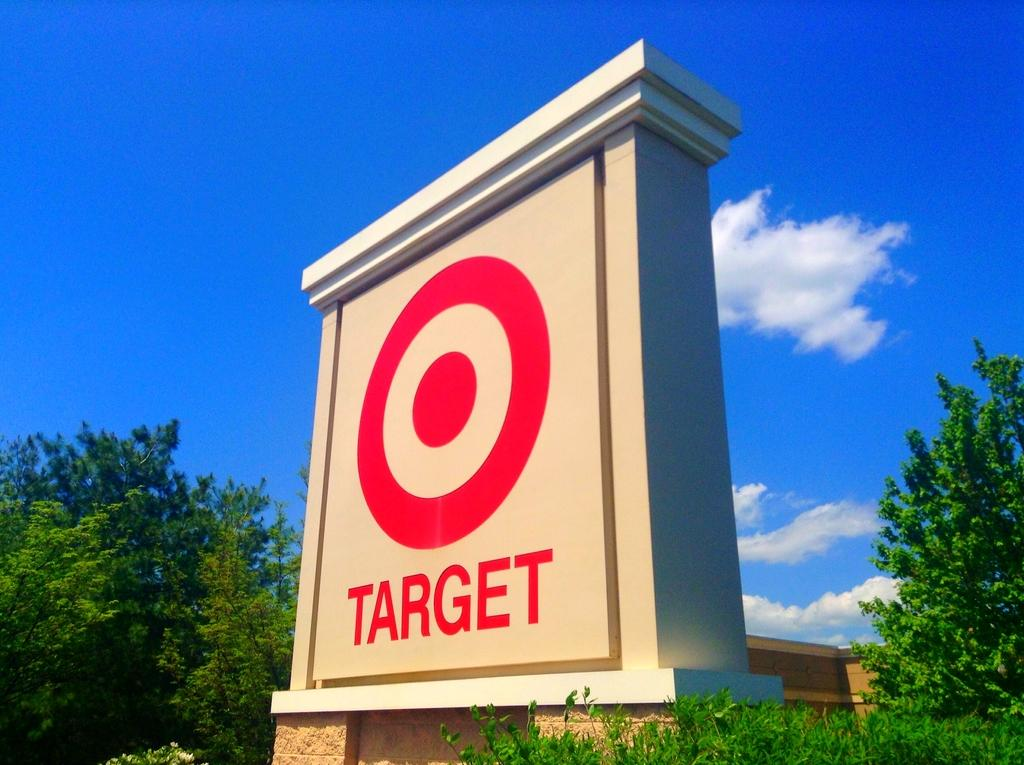What is the main object in the center of the image? There is a sign board in the center of the image. What type of vegetation can be seen on both sides of the image? There are trees on the right side and trees on the left side of the image. What is visible at the top of the image? The sky is visible at the top of the image. What level of self-awareness does the sign board exhibit in the image? The sign board does not exhibit any level of self-awareness, as it is an inanimate object. 